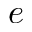Convert formula to latex. <formula><loc_0><loc_0><loc_500><loc_500>e</formula> 